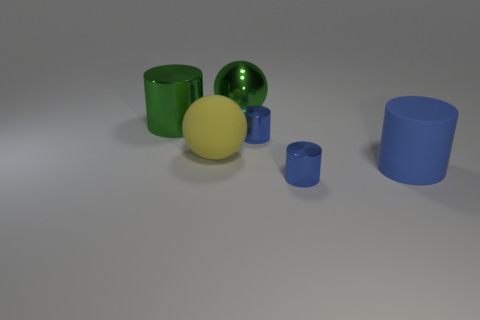There is a cylinder that is the same color as the big shiny sphere; what is it made of?
Give a very brief answer. Metal. What is the yellow ball made of?
Provide a succinct answer. Rubber. Is the object that is in front of the big blue cylinder made of the same material as the big blue object?
Give a very brief answer. No. There is a big thing in front of the big yellow thing; what is its shape?
Keep it short and to the point. Cylinder. There is another cylinder that is the same size as the green shiny cylinder; what is its material?
Offer a very short reply. Rubber. What number of objects are large things that are right of the big matte sphere or big cylinders that are behind the yellow rubber sphere?
Ensure brevity in your answer.  3. The green thing that is the same material as the green ball is what size?
Provide a short and direct response. Large. What number of rubber things are cylinders or large cylinders?
Offer a terse response. 1. What is the size of the blue rubber cylinder?
Provide a succinct answer. Large. Is the matte cylinder the same size as the green metallic sphere?
Provide a short and direct response. Yes. 